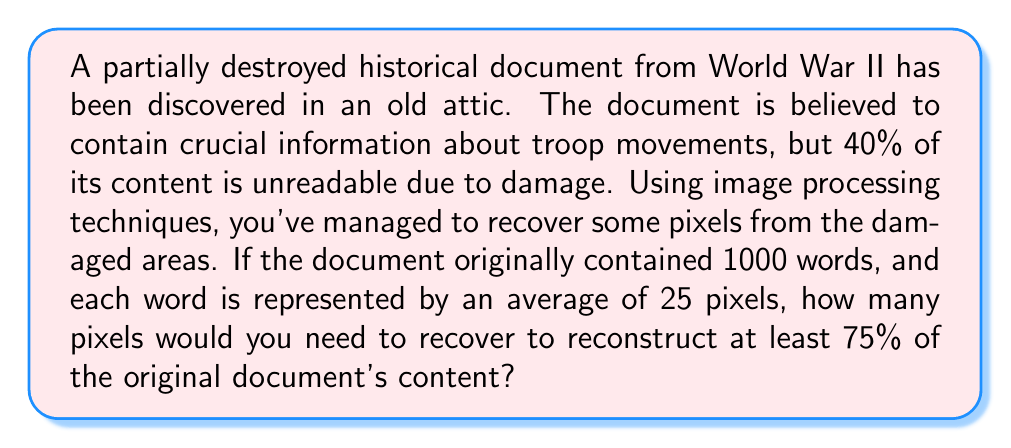Teach me how to tackle this problem. Let's approach this step-by-step:

1) First, let's calculate the total number of pixels in the original document:
   $$ \text{Total pixels} = 1000 \text{ words} \times 25 \text{ pixels/word} = 25000 \text{ pixels} $$

2) We know that 40% of the content is unreadable, which means 60% is still intact:
   $$ \text{Intact pixels} = 60\% \times 25000 = 0.6 \times 25000 = 15000 \text{ pixels} $$

3) We want to reconstruct at least 75% of the original document. So, we need to calculate how many pixels represent 75% of the document:
   $$ 75\% \text{ of total pixels} = 0.75 \times 25000 = 18750 \text{ pixels} $$

4) To find out how many pixels we need to recover, we subtract the intact pixels from the 75% target:
   $$ \text{Pixels to recover} = 18750 - 15000 = 3750 \text{ pixels} $$

Therefore, we need to recover at least 3750 pixels to reconstruct 75% of the original document's content.
Answer: 3750 pixels 